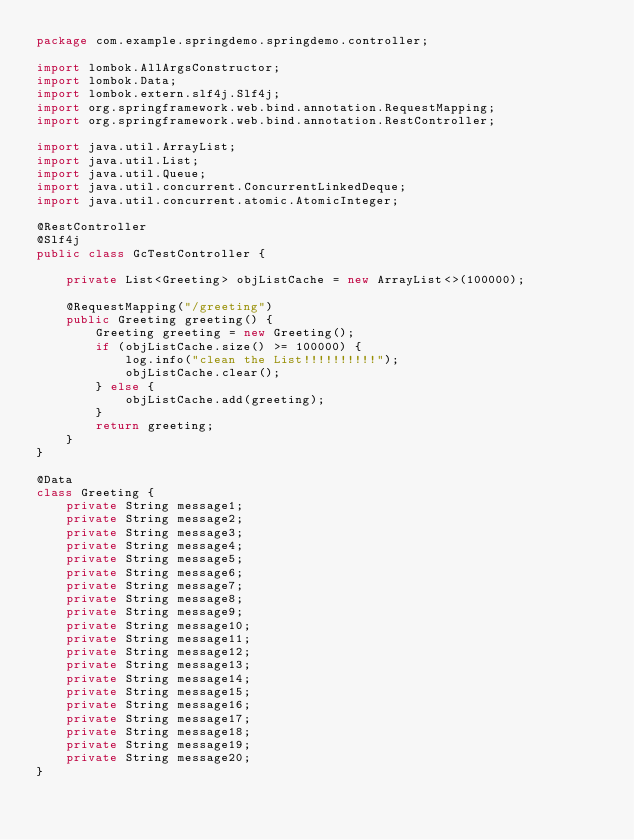Convert code to text. <code><loc_0><loc_0><loc_500><loc_500><_Java_>package com.example.springdemo.springdemo.controller;

import lombok.AllArgsConstructor;
import lombok.Data;
import lombok.extern.slf4j.Slf4j;
import org.springframework.web.bind.annotation.RequestMapping;
import org.springframework.web.bind.annotation.RestController;

import java.util.ArrayList;
import java.util.List;
import java.util.Queue;
import java.util.concurrent.ConcurrentLinkedDeque;
import java.util.concurrent.atomic.AtomicInteger;

@RestController
@Slf4j
public class GcTestController {

    private List<Greeting> objListCache = new ArrayList<>(100000);

    @RequestMapping("/greeting")
    public Greeting greeting() {
        Greeting greeting = new Greeting();
        if (objListCache.size() >= 100000) {
            log.info("clean the List!!!!!!!!!!");
            objListCache.clear();
        } else {
            objListCache.add(greeting);
        }
        return greeting;
    }
}

@Data
class Greeting {
    private String message1;
    private String message2;
    private String message3;
    private String message4;
    private String message5;
    private String message6;
    private String message7;
    private String message8;
    private String message9;
    private String message10;
    private String message11;
    private String message12;
    private String message13;
    private String message14;
    private String message15;
    private String message16;
    private String message17;
    private String message18;
    private String message19;
    private String message20;
}</code> 